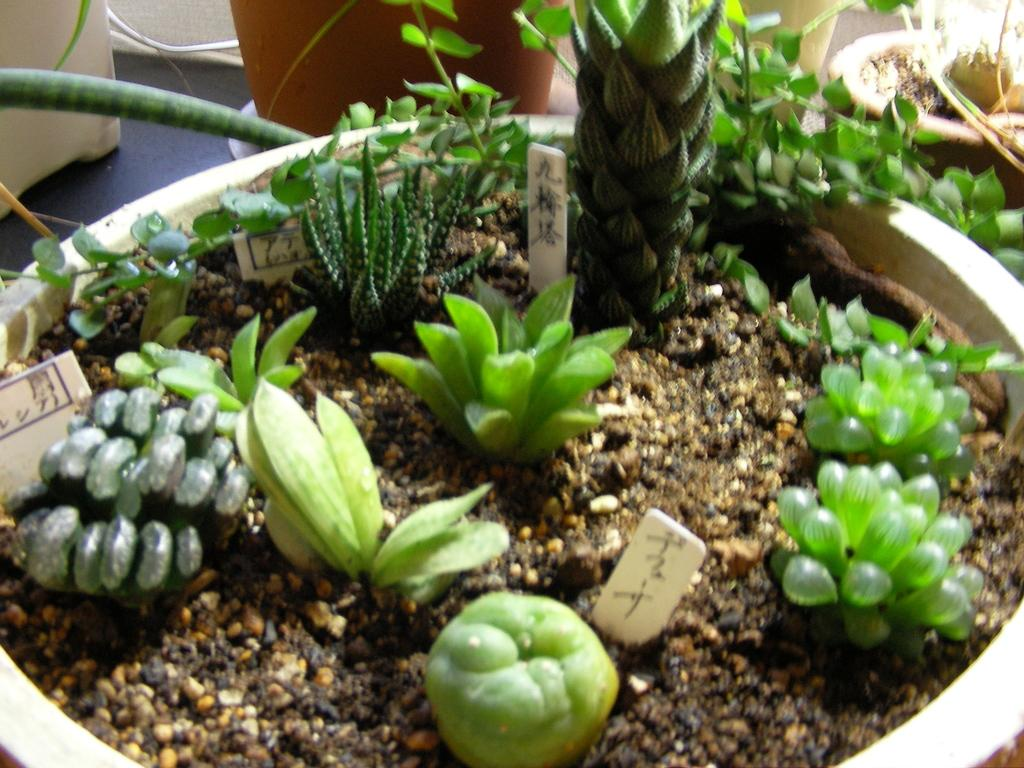What objects are placed on the floor in the image? There are flower pots on the floor in the image. What type of living organisms can be seen in the image? There are plants in the image. What other objects can be seen in the image? There are boards in the image. How does the girl adjust the snow in the image? There is no girl or snow present in the image; it features flower pots, plants, and boards. 